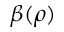<formula> <loc_0><loc_0><loc_500><loc_500>\beta ( \rho )</formula> 